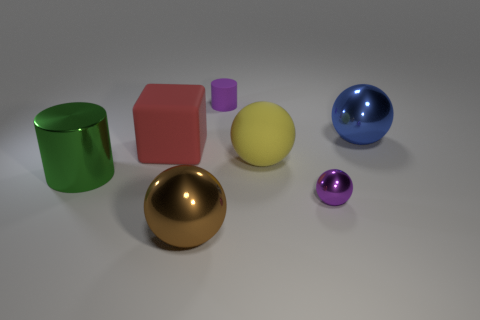How would you differentiate the textures of the objects shown? The green cylinder and the spheres, particularly the blue and golden ones, have shiny, smooth textures suggesting a glossy finish. The large red cube appears to have a matte finish with little to no reflection, suggesting a non-glossy texture. The small purple cylinder has a subtle shine, indicating a semi-gloss texture. The yellow sphere seems to have a diffuse reflection, which might indicate a slightly textured or matte surface. 